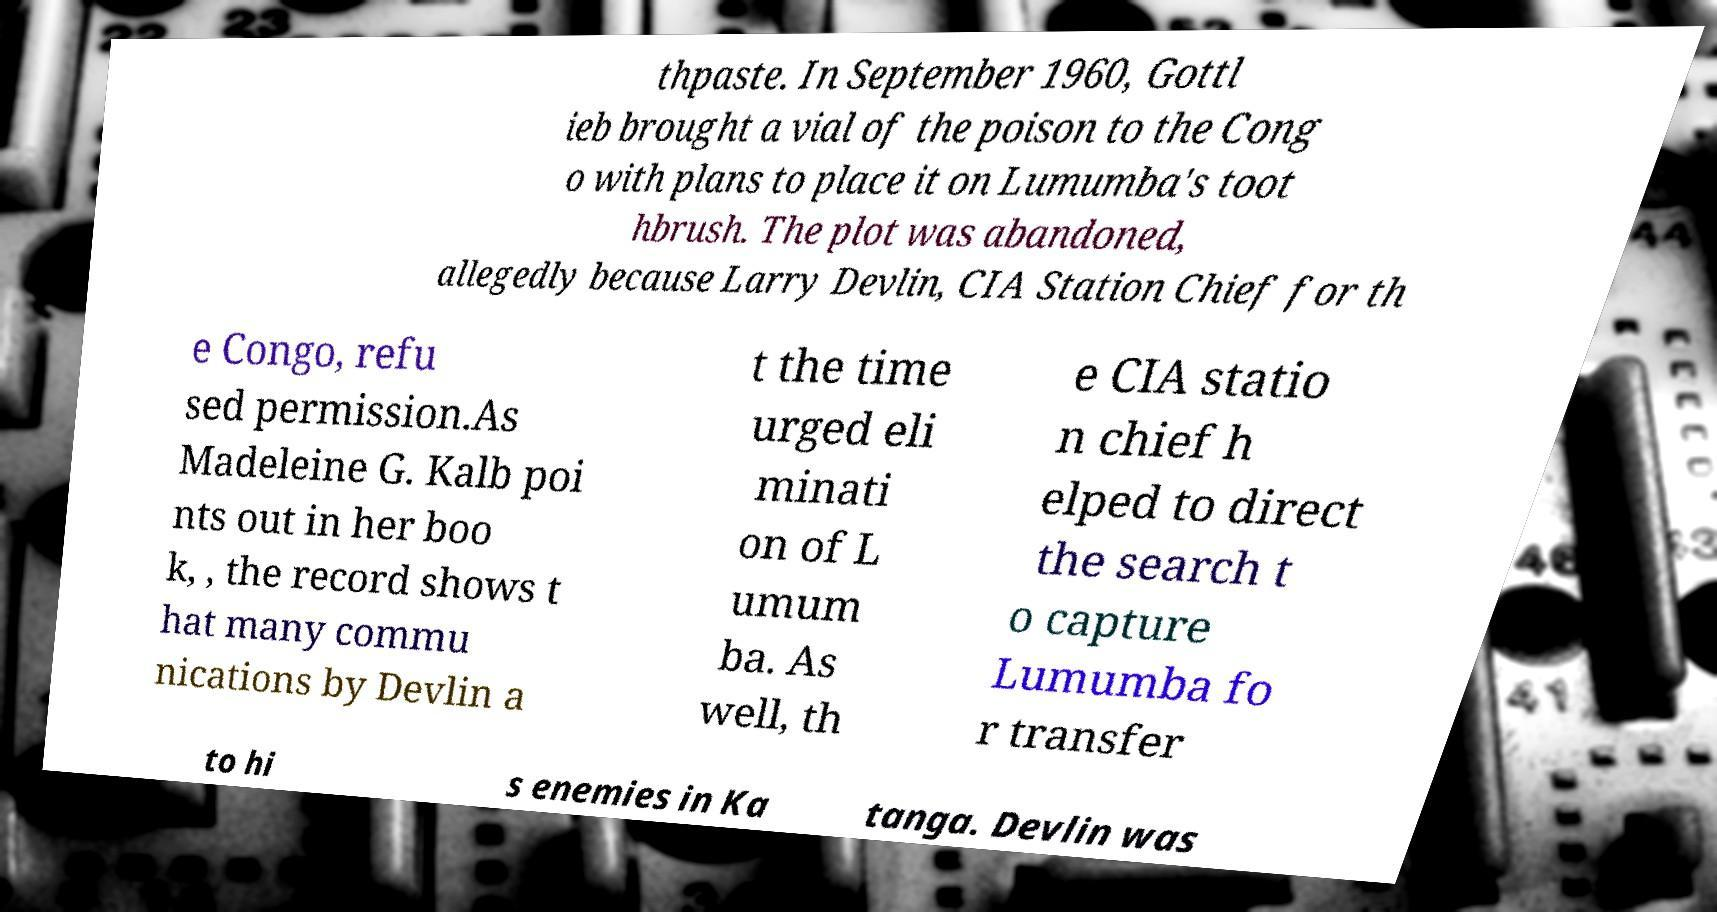Can you accurately transcribe the text from the provided image for me? thpaste. In September 1960, Gottl ieb brought a vial of the poison to the Cong o with plans to place it on Lumumba's toot hbrush. The plot was abandoned, allegedly because Larry Devlin, CIA Station Chief for th e Congo, refu sed permission.As Madeleine G. Kalb poi nts out in her boo k, , the record shows t hat many commu nications by Devlin a t the time urged eli minati on of L umum ba. As well, th e CIA statio n chief h elped to direct the search t o capture Lumumba fo r transfer to hi s enemies in Ka tanga. Devlin was 